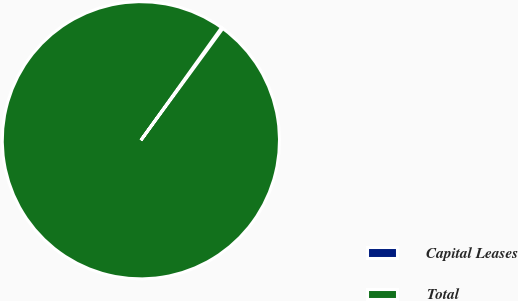Convert chart. <chart><loc_0><loc_0><loc_500><loc_500><pie_chart><fcel>Capital Leases<fcel>Total<nl><fcel>0.18%<fcel>99.82%<nl></chart> 